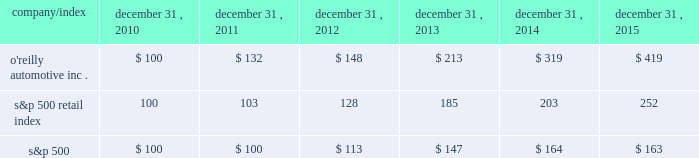Stock performance graph : the graph below shows the cumulative total shareholder return assuming the investment of $ 100 , on december 31 , 2010 , and the reinvestment of dividends thereafter , if any , in the company's common stock versus the standard and poor's s&p 500 retail index ( "s&p 500 retail index" ) and the standard and poor's s&p 500 index ( "s&p 500" ) . .

Did the five year return of the s&p 500 retail index outperform the s&p 500? 
Computations: (252 > 163)
Answer: yes. 